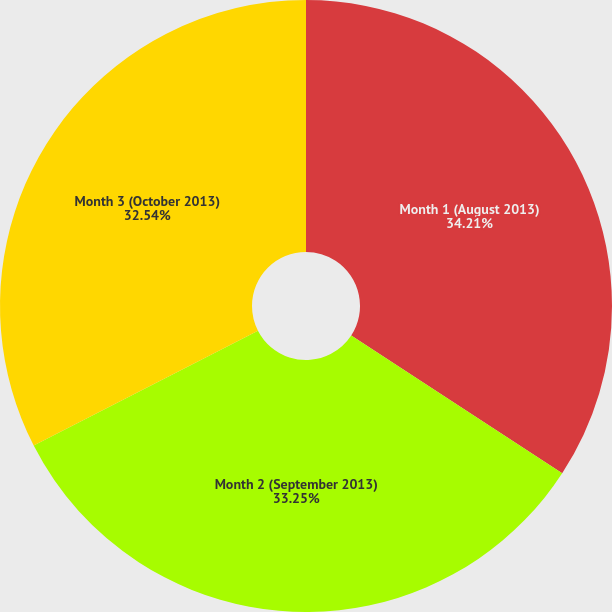<chart> <loc_0><loc_0><loc_500><loc_500><pie_chart><fcel>Month 1 (August 2013)<fcel>Month 2 (September 2013)<fcel>Month 3 (October 2013)<nl><fcel>34.21%<fcel>33.25%<fcel>32.54%<nl></chart> 